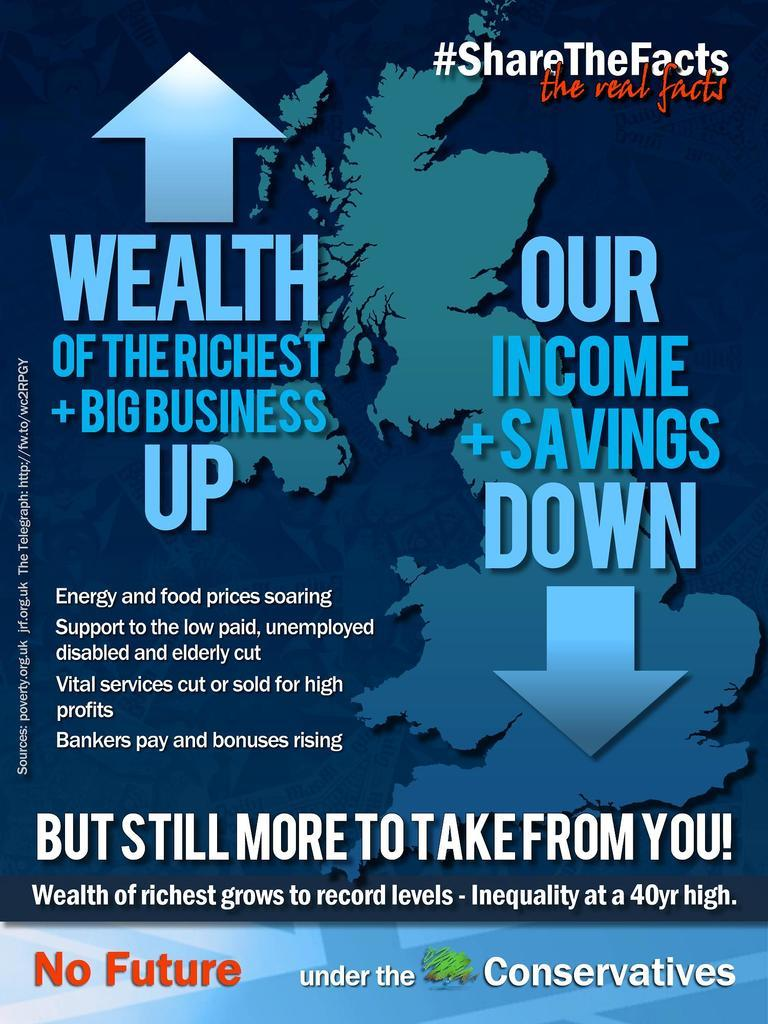Provide a one-sentence caption for the provided image. out about Wealth of the Richest Big Business in this reading material. 